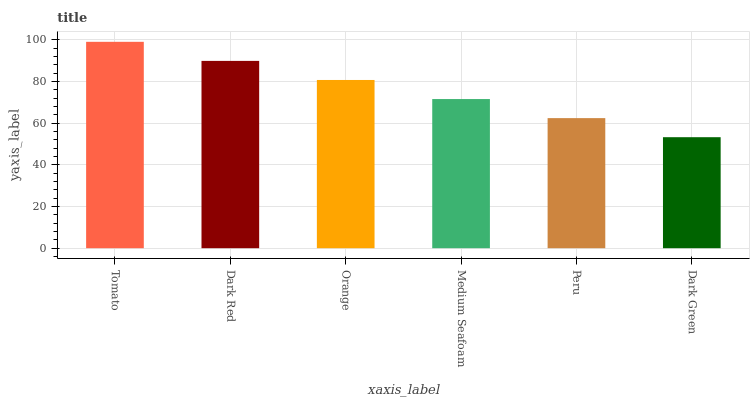Is Dark Green the minimum?
Answer yes or no. Yes. Is Tomato the maximum?
Answer yes or no. Yes. Is Dark Red the minimum?
Answer yes or no. No. Is Dark Red the maximum?
Answer yes or no. No. Is Tomato greater than Dark Red?
Answer yes or no. Yes. Is Dark Red less than Tomato?
Answer yes or no. Yes. Is Dark Red greater than Tomato?
Answer yes or no. No. Is Tomato less than Dark Red?
Answer yes or no. No. Is Orange the high median?
Answer yes or no. Yes. Is Medium Seafoam the low median?
Answer yes or no. Yes. Is Dark Green the high median?
Answer yes or no. No. Is Dark Red the low median?
Answer yes or no. No. 